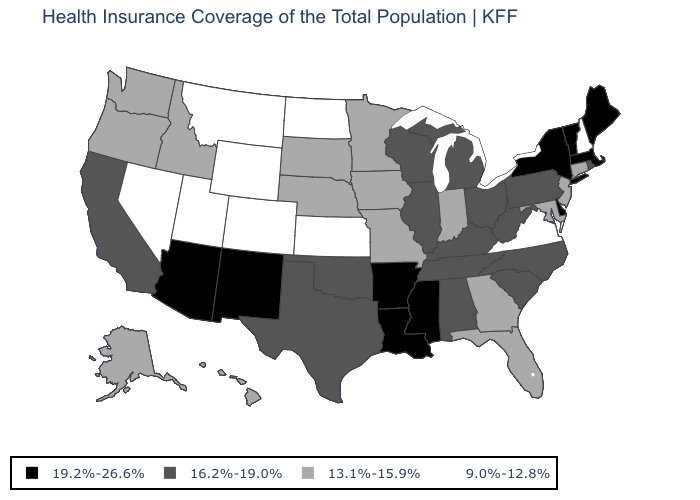Among the states that border Utah , which have the lowest value?
Write a very short answer. Colorado, Nevada, Wyoming. Among the states that border Nevada , does Oregon have the highest value?
Answer briefly. No. Does the first symbol in the legend represent the smallest category?
Be succinct. No. Among the states that border Ohio , does Kentucky have the highest value?
Concise answer only. Yes. Among the states that border Missouri , does Oklahoma have the lowest value?
Keep it brief. No. Name the states that have a value in the range 9.0%-12.8%?
Answer briefly. Colorado, Kansas, Montana, Nevada, New Hampshire, North Dakota, Utah, Virginia, Wyoming. Does Connecticut have the same value as Rhode Island?
Answer briefly. No. What is the value of Kentucky?
Answer briefly. 16.2%-19.0%. How many symbols are there in the legend?
Be succinct. 4. Does Kansas have the highest value in the USA?
Give a very brief answer. No. What is the lowest value in the USA?
Short answer required. 9.0%-12.8%. What is the value of Utah?
Answer briefly. 9.0%-12.8%. Does the first symbol in the legend represent the smallest category?
Be succinct. No. Among the states that border Ohio , which have the lowest value?
Concise answer only. Indiana. Name the states that have a value in the range 19.2%-26.6%?
Give a very brief answer. Arizona, Arkansas, Delaware, Louisiana, Maine, Massachusetts, Mississippi, New Mexico, New York, Vermont. 